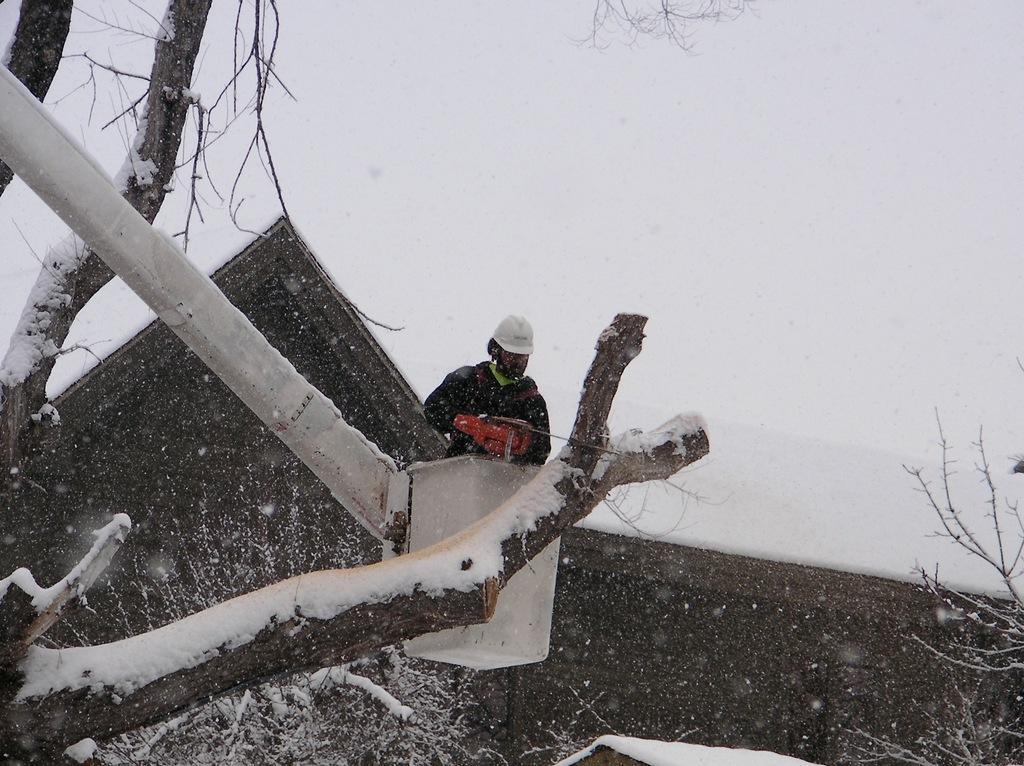Can you describe this image briefly? There is a man in a crane and holding a tool and wore helmet. We can see trees and snow. In the background it is white. 